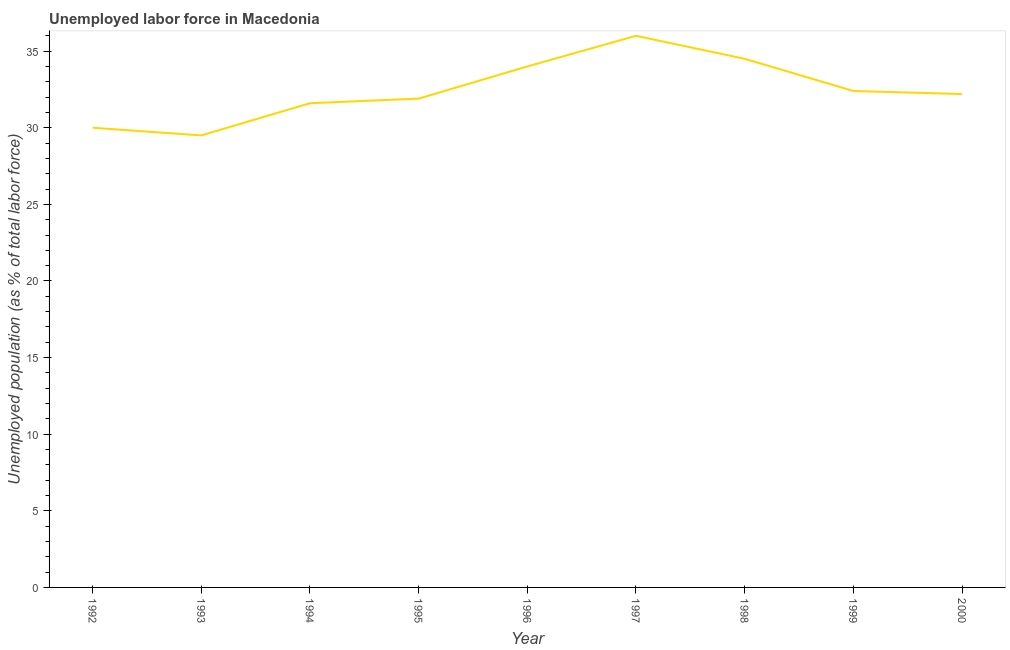Across all years, what is the minimum total unemployed population?
Give a very brief answer. 29.5. In which year was the total unemployed population maximum?
Your answer should be very brief. 1997. What is the sum of the total unemployed population?
Offer a very short reply. 292.1. What is the average total unemployed population per year?
Ensure brevity in your answer.  32.46. What is the median total unemployed population?
Provide a succinct answer. 32.2. Do a majority of the years between 1993 and 1997 (inclusive) have total unemployed population greater than 35 %?
Ensure brevity in your answer.  No. What is the ratio of the total unemployed population in 1996 to that in 1998?
Ensure brevity in your answer.  0.99. Is the total unemployed population in 1995 less than that in 2000?
Make the answer very short. Yes. What is the difference between the highest and the lowest total unemployed population?
Make the answer very short. 6.5. In how many years, is the total unemployed population greater than the average total unemployed population taken over all years?
Your answer should be very brief. 3. Does the total unemployed population monotonically increase over the years?
Make the answer very short. No. How many lines are there?
Your answer should be compact. 1. How many years are there in the graph?
Your response must be concise. 9. What is the title of the graph?
Provide a short and direct response. Unemployed labor force in Macedonia. What is the label or title of the X-axis?
Provide a short and direct response. Year. What is the label or title of the Y-axis?
Your response must be concise. Unemployed population (as % of total labor force). What is the Unemployed population (as % of total labor force) in 1992?
Your answer should be very brief. 30. What is the Unemployed population (as % of total labor force) in 1993?
Make the answer very short. 29.5. What is the Unemployed population (as % of total labor force) of 1994?
Keep it short and to the point. 31.6. What is the Unemployed population (as % of total labor force) in 1995?
Keep it short and to the point. 31.9. What is the Unemployed population (as % of total labor force) of 1998?
Offer a terse response. 34.5. What is the Unemployed population (as % of total labor force) in 1999?
Make the answer very short. 32.4. What is the Unemployed population (as % of total labor force) of 2000?
Give a very brief answer. 32.2. What is the difference between the Unemployed population (as % of total labor force) in 1992 and 1993?
Your answer should be very brief. 0.5. What is the difference between the Unemployed population (as % of total labor force) in 1992 and 1994?
Your answer should be compact. -1.6. What is the difference between the Unemployed population (as % of total labor force) in 1992 and 1995?
Make the answer very short. -1.9. What is the difference between the Unemployed population (as % of total labor force) in 1992 and 1996?
Offer a terse response. -4. What is the difference between the Unemployed population (as % of total labor force) in 1992 and 1997?
Your answer should be compact. -6. What is the difference between the Unemployed population (as % of total labor force) in 1992 and 1998?
Your response must be concise. -4.5. What is the difference between the Unemployed population (as % of total labor force) in 1993 and 1994?
Your answer should be very brief. -2.1. What is the difference between the Unemployed population (as % of total labor force) in 1993 and 1996?
Make the answer very short. -4.5. What is the difference between the Unemployed population (as % of total labor force) in 1993 and 1997?
Ensure brevity in your answer.  -6.5. What is the difference between the Unemployed population (as % of total labor force) in 1993 and 1999?
Make the answer very short. -2.9. What is the difference between the Unemployed population (as % of total labor force) in 1993 and 2000?
Your response must be concise. -2.7. What is the difference between the Unemployed population (as % of total labor force) in 1994 and 1997?
Provide a succinct answer. -4.4. What is the difference between the Unemployed population (as % of total labor force) in 1994 and 1998?
Your answer should be very brief. -2.9. What is the difference between the Unemployed population (as % of total labor force) in 1994 and 1999?
Ensure brevity in your answer.  -0.8. What is the difference between the Unemployed population (as % of total labor force) in 1994 and 2000?
Give a very brief answer. -0.6. What is the difference between the Unemployed population (as % of total labor force) in 1995 and 1996?
Keep it short and to the point. -2.1. What is the difference between the Unemployed population (as % of total labor force) in 1995 and 1997?
Provide a short and direct response. -4.1. What is the difference between the Unemployed population (as % of total labor force) in 1995 and 1998?
Your response must be concise. -2.6. What is the difference between the Unemployed population (as % of total labor force) in 1996 and 1997?
Your response must be concise. -2. What is the difference between the Unemployed population (as % of total labor force) in 1996 and 1998?
Keep it short and to the point. -0.5. What is the difference between the Unemployed population (as % of total labor force) in 1996 and 2000?
Offer a very short reply. 1.8. What is the difference between the Unemployed population (as % of total labor force) in 1997 and 1998?
Make the answer very short. 1.5. What is the difference between the Unemployed population (as % of total labor force) in 1997 and 1999?
Your answer should be very brief. 3.6. What is the difference between the Unemployed population (as % of total labor force) in 1998 and 2000?
Keep it short and to the point. 2.3. What is the ratio of the Unemployed population (as % of total labor force) in 1992 to that in 1993?
Make the answer very short. 1.02. What is the ratio of the Unemployed population (as % of total labor force) in 1992 to that in 1994?
Your response must be concise. 0.95. What is the ratio of the Unemployed population (as % of total labor force) in 1992 to that in 1996?
Offer a terse response. 0.88. What is the ratio of the Unemployed population (as % of total labor force) in 1992 to that in 1997?
Provide a succinct answer. 0.83. What is the ratio of the Unemployed population (as % of total labor force) in 1992 to that in 1998?
Your answer should be very brief. 0.87. What is the ratio of the Unemployed population (as % of total labor force) in 1992 to that in 1999?
Make the answer very short. 0.93. What is the ratio of the Unemployed population (as % of total labor force) in 1992 to that in 2000?
Keep it short and to the point. 0.93. What is the ratio of the Unemployed population (as % of total labor force) in 1993 to that in 1994?
Provide a short and direct response. 0.93. What is the ratio of the Unemployed population (as % of total labor force) in 1993 to that in 1995?
Your answer should be very brief. 0.93. What is the ratio of the Unemployed population (as % of total labor force) in 1993 to that in 1996?
Give a very brief answer. 0.87. What is the ratio of the Unemployed population (as % of total labor force) in 1993 to that in 1997?
Your answer should be very brief. 0.82. What is the ratio of the Unemployed population (as % of total labor force) in 1993 to that in 1998?
Ensure brevity in your answer.  0.85. What is the ratio of the Unemployed population (as % of total labor force) in 1993 to that in 1999?
Give a very brief answer. 0.91. What is the ratio of the Unemployed population (as % of total labor force) in 1993 to that in 2000?
Provide a short and direct response. 0.92. What is the ratio of the Unemployed population (as % of total labor force) in 1994 to that in 1996?
Offer a terse response. 0.93. What is the ratio of the Unemployed population (as % of total labor force) in 1994 to that in 1997?
Make the answer very short. 0.88. What is the ratio of the Unemployed population (as % of total labor force) in 1994 to that in 1998?
Ensure brevity in your answer.  0.92. What is the ratio of the Unemployed population (as % of total labor force) in 1994 to that in 2000?
Provide a short and direct response. 0.98. What is the ratio of the Unemployed population (as % of total labor force) in 1995 to that in 1996?
Your answer should be very brief. 0.94. What is the ratio of the Unemployed population (as % of total labor force) in 1995 to that in 1997?
Your response must be concise. 0.89. What is the ratio of the Unemployed population (as % of total labor force) in 1995 to that in 1998?
Offer a very short reply. 0.93. What is the ratio of the Unemployed population (as % of total labor force) in 1995 to that in 1999?
Provide a short and direct response. 0.98. What is the ratio of the Unemployed population (as % of total labor force) in 1995 to that in 2000?
Ensure brevity in your answer.  0.99. What is the ratio of the Unemployed population (as % of total labor force) in 1996 to that in 1997?
Make the answer very short. 0.94. What is the ratio of the Unemployed population (as % of total labor force) in 1996 to that in 1998?
Give a very brief answer. 0.99. What is the ratio of the Unemployed population (as % of total labor force) in 1996 to that in 1999?
Your answer should be very brief. 1.05. What is the ratio of the Unemployed population (as % of total labor force) in 1996 to that in 2000?
Provide a short and direct response. 1.06. What is the ratio of the Unemployed population (as % of total labor force) in 1997 to that in 1998?
Provide a short and direct response. 1.04. What is the ratio of the Unemployed population (as % of total labor force) in 1997 to that in 1999?
Offer a very short reply. 1.11. What is the ratio of the Unemployed population (as % of total labor force) in 1997 to that in 2000?
Give a very brief answer. 1.12. What is the ratio of the Unemployed population (as % of total labor force) in 1998 to that in 1999?
Offer a very short reply. 1.06. What is the ratio of the Unemployed population (as % of total labor force) in 1998 to that in 2000?
Offer a terse response. 1.07. What is the ratio of the Unemployed population (as % of total labor force) in 1999 to that in 2000?
Provide a succinct answer. 1.01. 